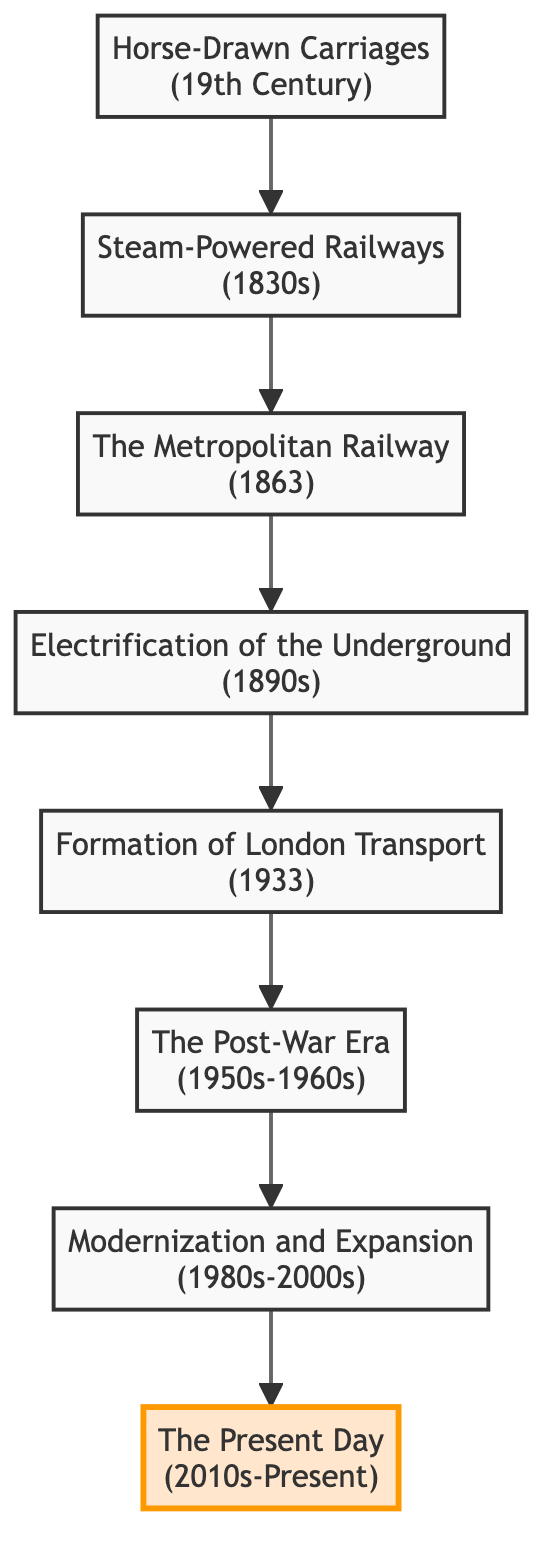What is the first mode of transport depicted in the diagram? The first node shown in the diagram is "Horse-Drawn Carriages," which represents the initial stage of London's transport system in the 19th century.
Answer: Horse-Drawn Carriages How many stages of development are represented in the diagram? By counting each node from Horse-Drawn Carriages at the bottom to The Present Day at the top, we find there are eight distinct stages in the development of London’s transport system.
Answer: 8 What year did the Metropolitan Railway open? The node labeled "The Metropolitan Railway" indicates that it opened in 1863, which is explicitly mentioned in the description of that stage.
Answer: 1863 Which stage marks the transition to electric trains in the Underground? The diagram highlights "Electrification of the Underground," which is noted as the first line to use electric trains, making it the transition stage to cleaner transport.
Answer: Electrification of the Underground What major change occurred in 1933 regarding London's transport? The node "Formation of London Transport" signifies that in 1933, all major transport services like buses, trams, and the Underground were brought under one organization for better coordination.
Answer: Formation of London Transport What is the time period for the Post-War Era in London’s transport development? The description provided under the node "The Post-War Era" specifies the time period as the 1950s to 1960s, encapsulating this era of transport expansion and modernization.
Answer: 1950s-1960s Which stage represents the present day transport system of London? The last node at the top of the diagram is labeled "The Present Day," indicating this is the current stage of London's transport system as overseen by Transport for London (TfL).
Answer: The Present Day How did the introduction of London Transport improve city services? The node describing "Formation of London Transport" states that it led to more coordinated and efficient service across the city, reflecting the improvements achieved through organizational consolidation.
Answer: More coordinated and efficient service What was a key feature of the expansion in the 1980s-2000s? The stage "Modernization and Expansion" describes significant investments made to update the infrastructure, specifically mentioning extensions like the Jubilee Line expansion, which highlights this key feature.
Answer: Jubilee Line expansion 